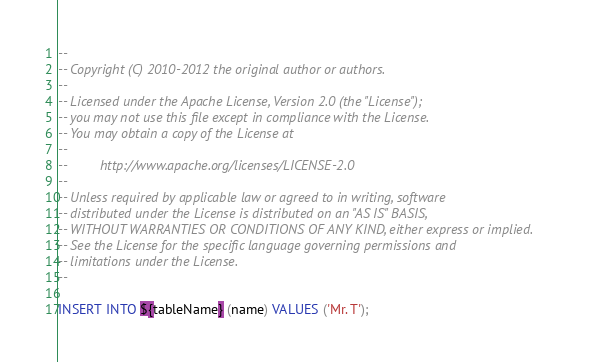Convert code to text. <code><loc_0><loc_0><loc_500><loc_500><_SQL_>--
-- Copyright (C) 2010-2012 the original author or authors.
--
-- Licensed under the Apache License, Version 2.0 (the "License");
-- you may not use this file except in compliance with the License.
-- You may obtain a copy of the License at
--
--         http://www.apache.org/licenses/LICENSE-2.0
--
-- Unless required by applicable law or agreed to in writing, software
-- distributed under the License is distributed on an "AS IS" BASIS,
-- WITHOUT WARRANTIES OR CONDITIONS OF ANY KIND, either express or implied.
-- See the License for the specific language governing permissions and
-- limitations under the License.
--

INSERT INTO ${tableName} (name) VALUES ('Mr. T');</code> 